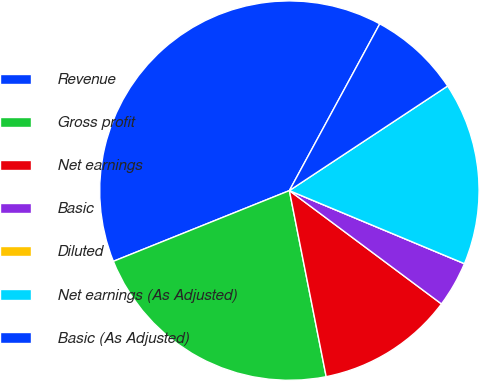Convert chart to OTSL. <chart><loc_0><loc_0><loc_500><loc_500><pie_chart><fcel>Revenue<fcel>Gross profit<fcel>Net earnings<fcel>Basic<fcel>Diluted<fcel>Net earnings (As Adjusted)<fcel>Basic (As Adjusted)<nl><fcel>38.99%<fcel>22.03%<fcel>11.7%<fcel>3.9%<fcel>0.0%<fcel>15.59%<fcel>7.8%<nl></chart> 